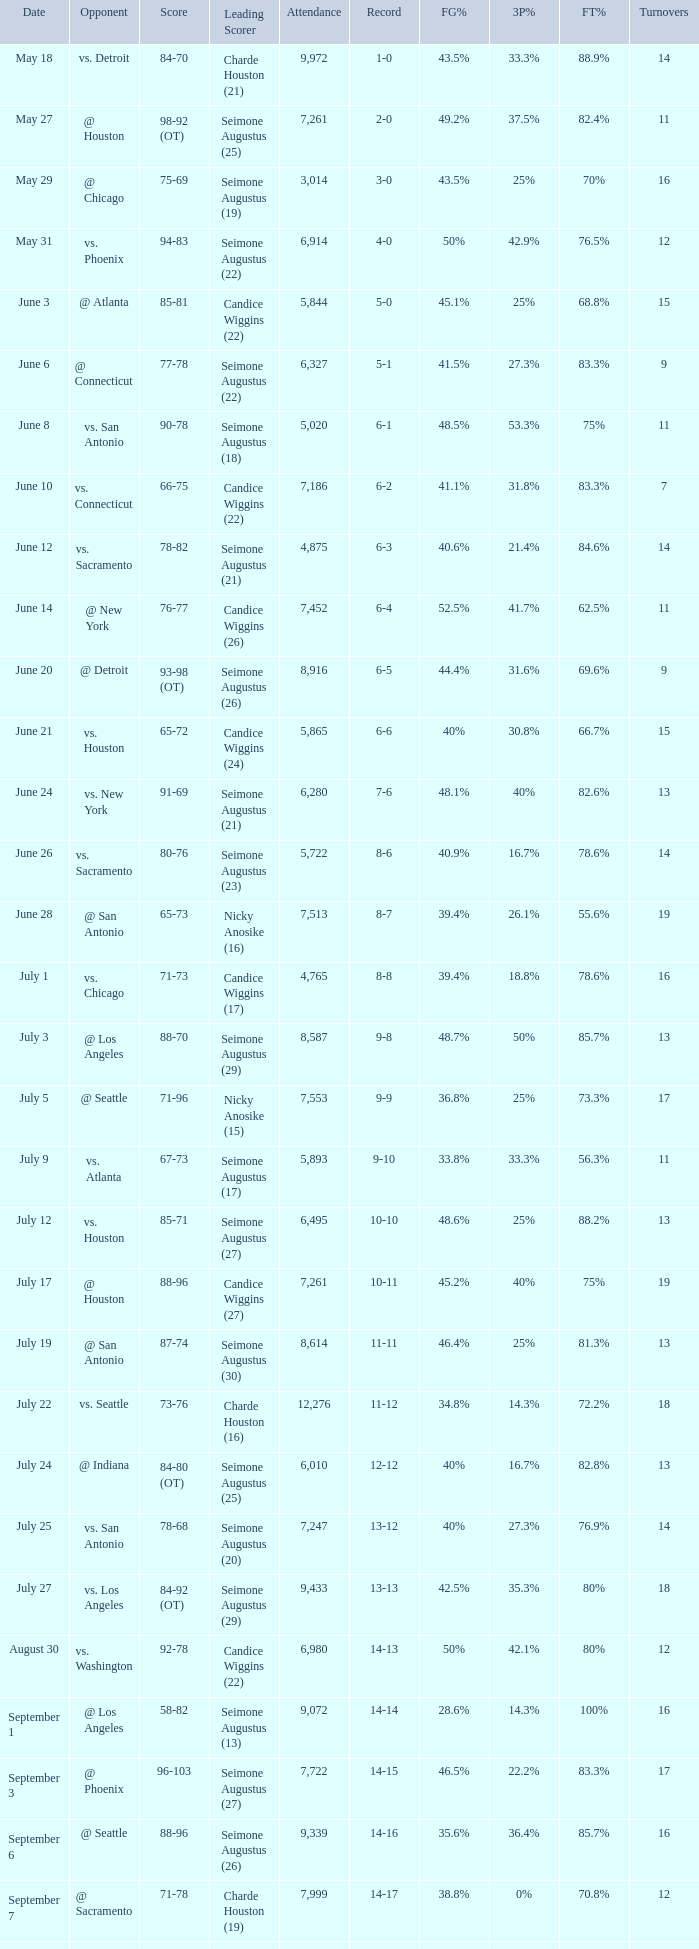Help me parse the entirety of this table. {'header': ['Date', 'Opponent', 'Score', 'Leading Scorer', 'Attendance', 'Record', 'FG%', '3P%', 'FT%', 'Turnovers'], 'rows': [['May 18', 'vs. Detroit', '84-70', 'Charde Houston (21)', '9,972', '1-0', '43.5%', '33.3%', '88.9%', '14'], ['May 27', '@ Houston', '98-92 (OT)', 'Seimone Augustus (25)', '7,261', '2-0', '49.2%', '37.5%', '82.4%', '11'], ['May 29', '@ Chicago', '75-69', 'Seimone Augustus (19)', '3,014', '3-0', '43.5%', '25%', '70%', '16'], ['May 31', 'vs. Phoenix', '94-83', 'Seimone Augustus (22)', '6,914', '4-0', '50%', '42.9%', '76.5%', '12'], ['June 3', '@ Atlanta', '85-81', 'Candice Wiggins (22)', '5,844', '5-0', '45.1%', '25%', '68.8%', '15'], ['June 6', '@ Connecticut', '77-78', 'Seimone Augustus (22)', '6,327', '5-1', '41.5%', '27.3%', '83.3%', '9'], ['June 8', 'vs. San Antonio', '90-78', 'Seimone Augustus (18)', '5,020', '6-1', '48.5%', '53.3%', '75%', '11'], ['June 10', 'vs. Connecticut', '66-75', 'Candice Wiggins (22)', '7,186', '6-2', '41.1%', '31.8%', '83.3%', '7'], ['June 12', 'vs. Sacramento', '78-82', 'Seimone Augustus (21)', '4,875', '6-3', '40.6%', '21.4%', '84.6%', '14'], ['June 14', '@ New York', '76-77', 'Candice Wiggins (26)', '7,452', '6-4', '52.5%', '41.7%', '62.5%', '11'], ['June 20', '@ Detroit', '93-98 (OT)', 'Seimone Augustus (26)', '8,916', '6-5', '44.4%', '31.6%', '69.6%', '9'], ['June 21', 'vs. Houston', '65-72', 'Candice Wiggins (24)', '5,865', '6-6', '40%', '30.8%', '66.7%', '15'], ['June 24', 'vs. New York', '91-69', 'Seimone Augustus (21)', '6,280', '7-6', '48.1%', '40%', '82.6%', '13'], ['June 26', 'vs. Sacramento', '80-76', 'Seimone Augustus (23)', '5,722', '8-6', '40.9%', '16.7%', '78.6%', '14'], ['June 28', '@ San Antonio', '65-73', 'Nicky Anosike (16)', '7,513', '8-7', '39.4%', '26.1%', '55.6%', '19'], ['July 1', 'vs. Chicago', '71-73', 'Candice Wiggins (17)', '4,765', '8-8', '39.4%', '18.8%', '78.6%', '16'], ['July 3', '@ Los Angeles', '88-70', 'Seimone Augustus (29)', '8,587', '9-8', '48.7%', '50%', '85.7%', '13'], ['July 5', '@ Seattle', '71-96', 'Nicky Anosike (15)', '7,553', '9-9', '36.8%', '25%', '73.3%', '17'], ['July 9', 'vs. Atlanta', '67-73', 'Seimone Augustus (17)', '5,893', '9-10', '33.8%', '33.3%', '56.3%', '11'], ['July 12', 'vs. Houston', '85-71', 'Seimone Augustus (27)', '6,495', '10-10', '48.6%', '25%', '88.2%', '13'], ['July 17', '@ Houston', '88-96', 'Candice Wiggins (27)', '7,261', '10-11', '45.2%', '40%', '75%', '19'], ['July 19', '@ San Antonio', '87-74', 'Seimone Augustus (30)', '8,614', '11-11', '46.4%', '25%', '81.3%', '13'], ['July 22', 'vs. Seattle', '73-76', 'Charde Houston (16)', '12,276', '11-12', '34.8%', '14.3%', '72.2%', '18'], ['July 24', '@ Indiana', '84-80 (OT)', 'Seimone Augustus (25)', '6,010', '12-12', '40%', '16.7%', '82.8%', '13'], ['July 25', 'vs. San Antonio', '78-68', 'Seimone Augustus (20)', '7,247', '13-12', '40%', '27.3%', '76.9%', '14'], ['July 27', 'vs. Los Angeles', '84-92 (OT)', 'Seimone Augustus (29)', '9,433', '13-13', '42.5%', '35.3%', '80%', '18'], ['August 30', 'vs. Washington', '92-78', 'Candice Wiggins (22)', '6,980', '14-13', '50%', '42.1%', '80%', '12'], ['September 1', '@ Los Angeles', '58-82', 'Seimone Augustus (13)', '9,072', '14-14', '28.6%', '14.3%', '100%', '16'], ['September 3', '@ Phoenix', '96-103', 'Seimone Augustus (27)', '7,722', '14-15', '46.5%', '22.2%', '83.3%', '17'], ['September 6', '@ Seattle', '88-96', 'Seimone Augustus (26)', '9,339', '14-16', '35.6%', '36.4%', '85.7%', '16'], ['September 7', '@ Sacramento', '71-78', 'Charde Houston (19)', '7,999', '14-17', '38.8%', '0%', '70.8%', '12'], ['September 9', 'vs. Indiana', '86-76', 'Charde Houston (18)', '6,706', '15-17', '45.6%', '40%', '66.7%', '12'], ['September 12', 'vs. Phoenix', '87-96', 'Lindsey Harding (20)', '8,343', '15-18', '46.4%', '16.7%', '69.2%', '15'], ['September 14', '@ Washington', '96-70', 'Charde Houston (18)', '10,438', '16-18', '55.4%', '46.2%', '88.2%', '10']]} Which Score has an Opponent of @ houston, and a Record of 2-0? 98-92 (OT). 